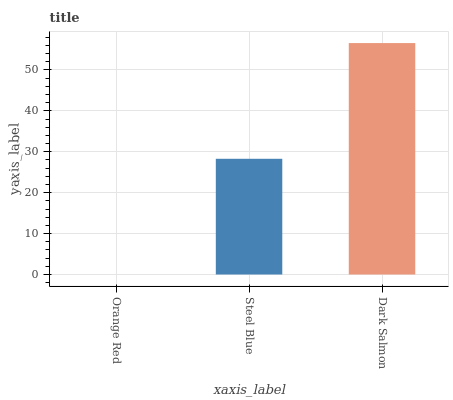Is Orange Red the minimum?
Answer yes or no. Yes. Is Dark Salmon the maximum?
Answer yes or no. Yes. Is Steel Blue the minimum?
Answer yes or no. No. Is Steel Blue the maximum?
Answer yes or no. No. Is Steel Blue greater than Orange Red?
Answer yes or no. Yes. Is Orange Red less than Steel Blue?
Answer yes or no. Yes. Is Orange Red greater than Steel Blue?
Answer yes or no. No. Is Steel Blue less than Orange Red?
Answer yes or no. No. Is Steel Blue the high median?
Answer yes or no. Yes. Is Steel Blue the low median?
Answer yes or no. Yes. Is Orange Red the high median?
Answer yes or no. No. Is Orange Red the low median?
Answer yes or no. No. 